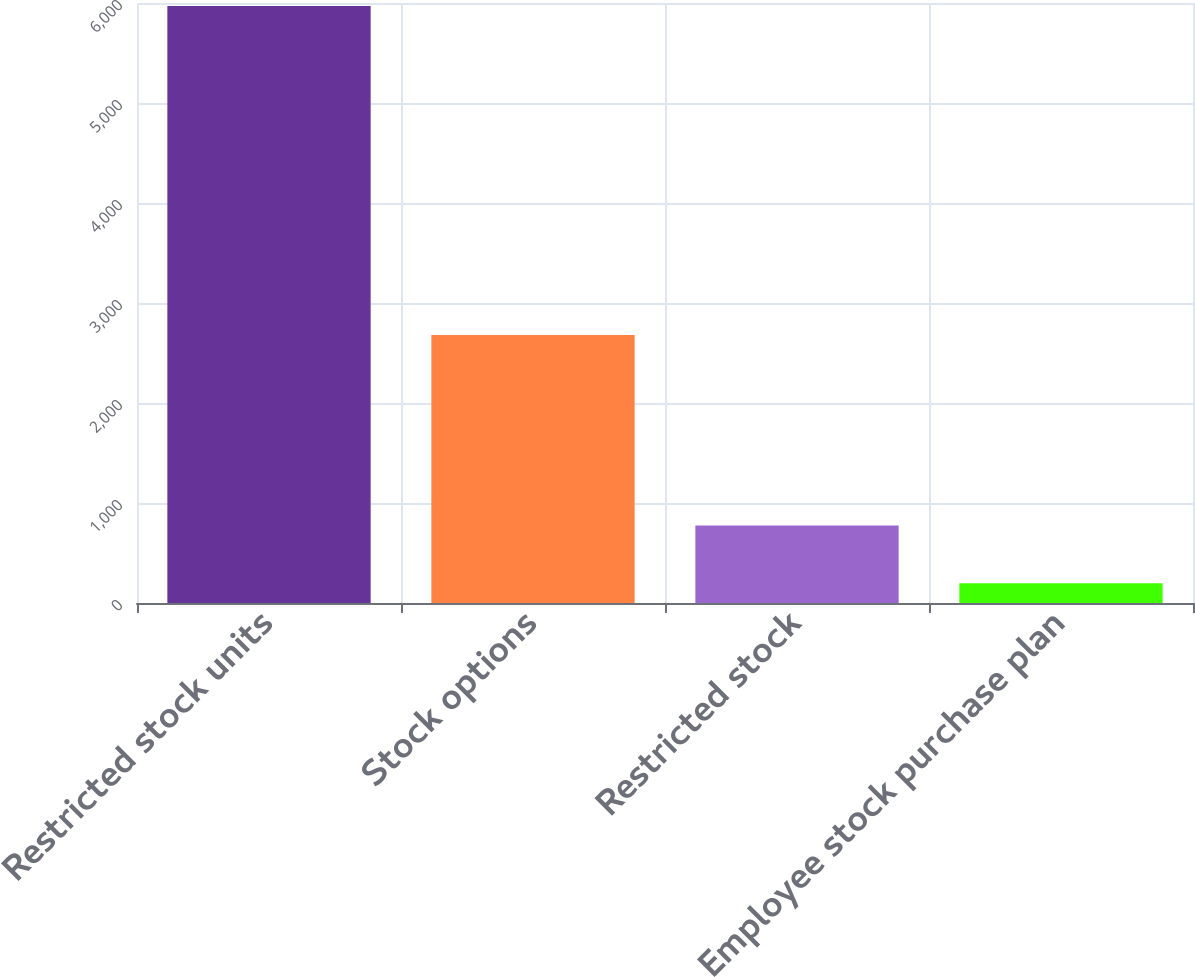Convert chart. <chart><loc_0><loc_0><loc_500><loc_500><bar_chart><fcel>Restricted stock units<fcel>Stock options<fcel>Restricted stock<fcel>Employee stock purchase plan<nl><fcel>5970<fcel>2680<fcel>775.2<fcel>198<nl></chart> 